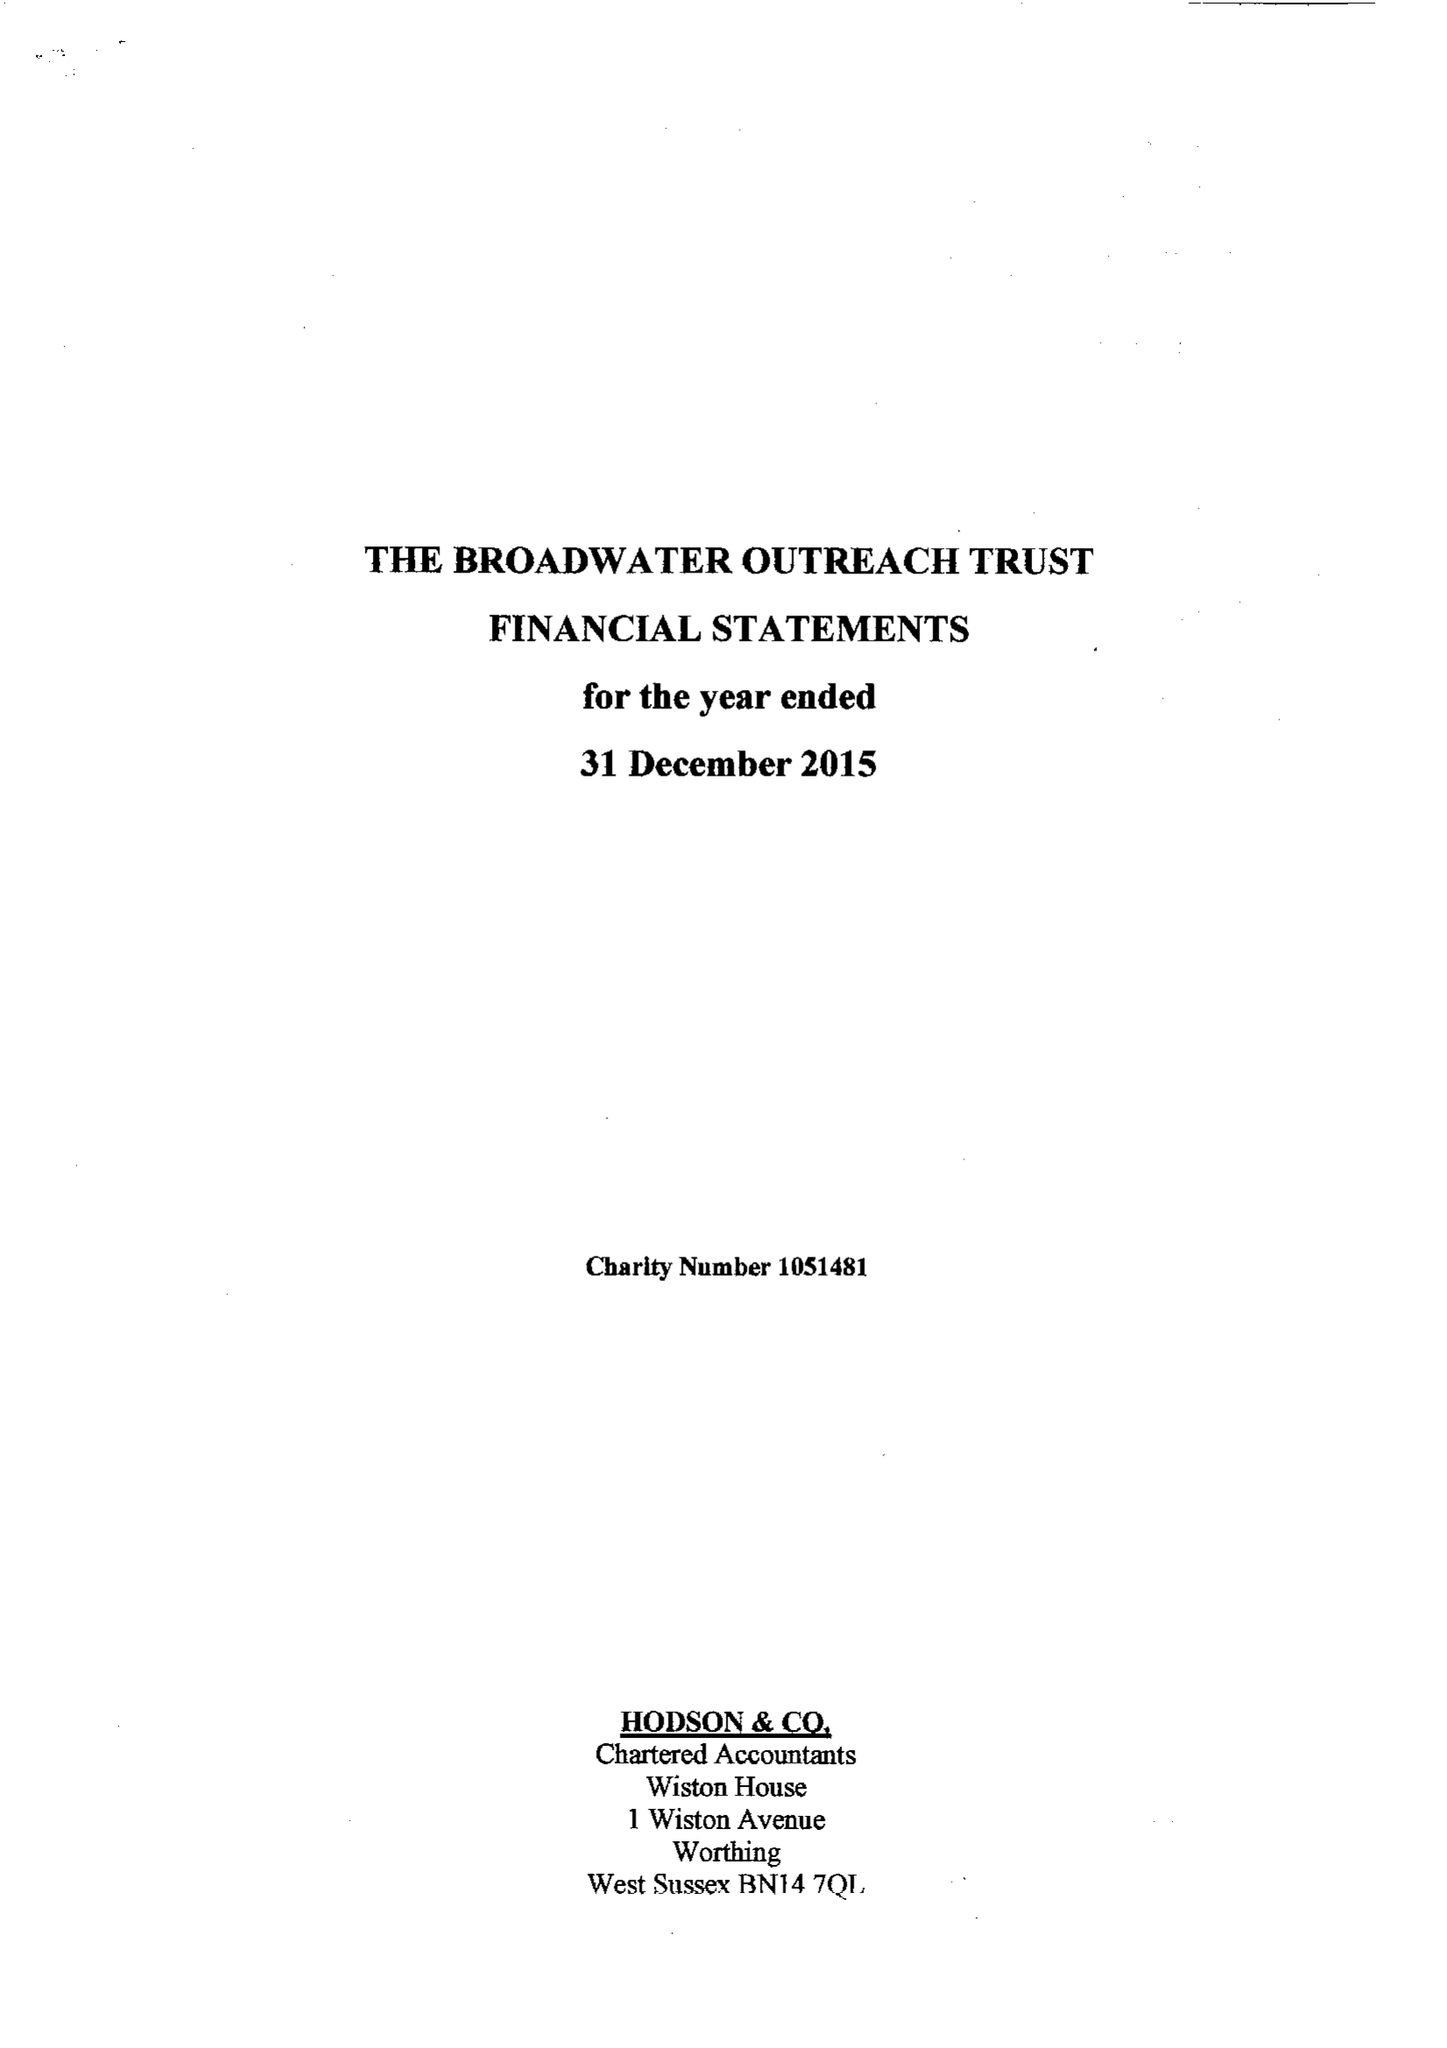What is the value for the spending_annually_in_british_pounds?
Answer the question using a single word or phrase. 27618.00 